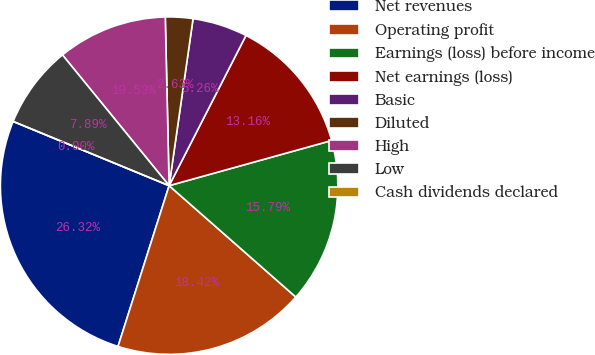Convert chart. <chart><loc_0><loc_0><loc_500><loc_500><pie_chart><fcel>Net revenues<fcel>Operating profit<fcel>Earnings (loss) before income<fcel>Net earnings (loss)<fcel>Basic<fcel>Diluted<fcel>High<fcel>Low<fcel>Cash dividends declared<nl><fcel>26.32%<fcel>18.42%<fcel>15.79%<fcel>13.16%<fcel>5.26%<fcel>2.63%<fcel>10.53%<fcel>7.89%<fcel>0.0%<nl></chart> 